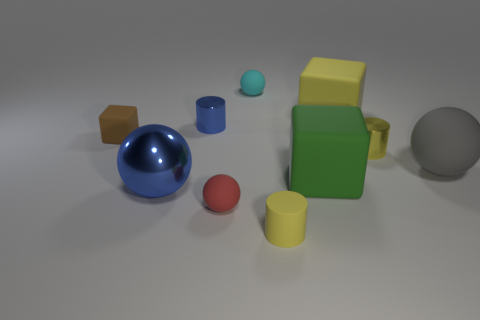Subtract all blocks. How many objects are left? 7 Subtract 0 gray cylinders. How many objects are left? 10 Subtract all large rubber spheres. Subtract all small cyan rubber balls. How many objects are left? 8 Add 7 yellow metallic objects. How many yellow metallic objects are left? 8 Add 9 big cyan matte cylinders. How many big cyan matte cylinders exist? 9 